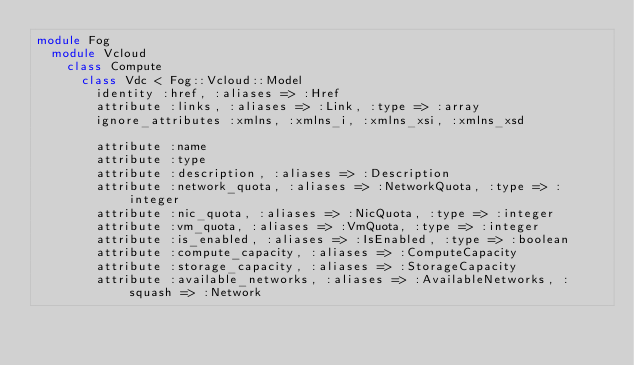<code> <loc_0><loc_0><loc_500><loc_500><_Ruby_>module Fog
  module Vcloud
    class Compute
      class Vdc < Fog::Vcloud::Model
        identity :href, :aliases => :Href
        attribute :links, :aliases => :Link, :type => :array
        ignore_attributes :xmlns, :xmlns_i, :xmlns_xsi, :xmlns_xsd

        attribute :name
        attribute :type
        attribute :description, :aliases => :Description
        attribute :network_quota, :aliases => :NetworkQuota, :type => :integer
        attribute :nic_quota, :aliases => :NicQuota, :type => :integer
        attribute :vm_quota, :aliases => :VmQuota, :type => :integer
        attribute :is_enabled, :aliases => :IsEnabled, :type => :boolean
        attribute :compute_capacity, :aliases => :ComputeCapacity
        attribute :storage_capacity, :aliases => :StorageCapacity
        attribute :available_networks, :aliases => :AvailableNetworks, :squash => :Network
</code> 